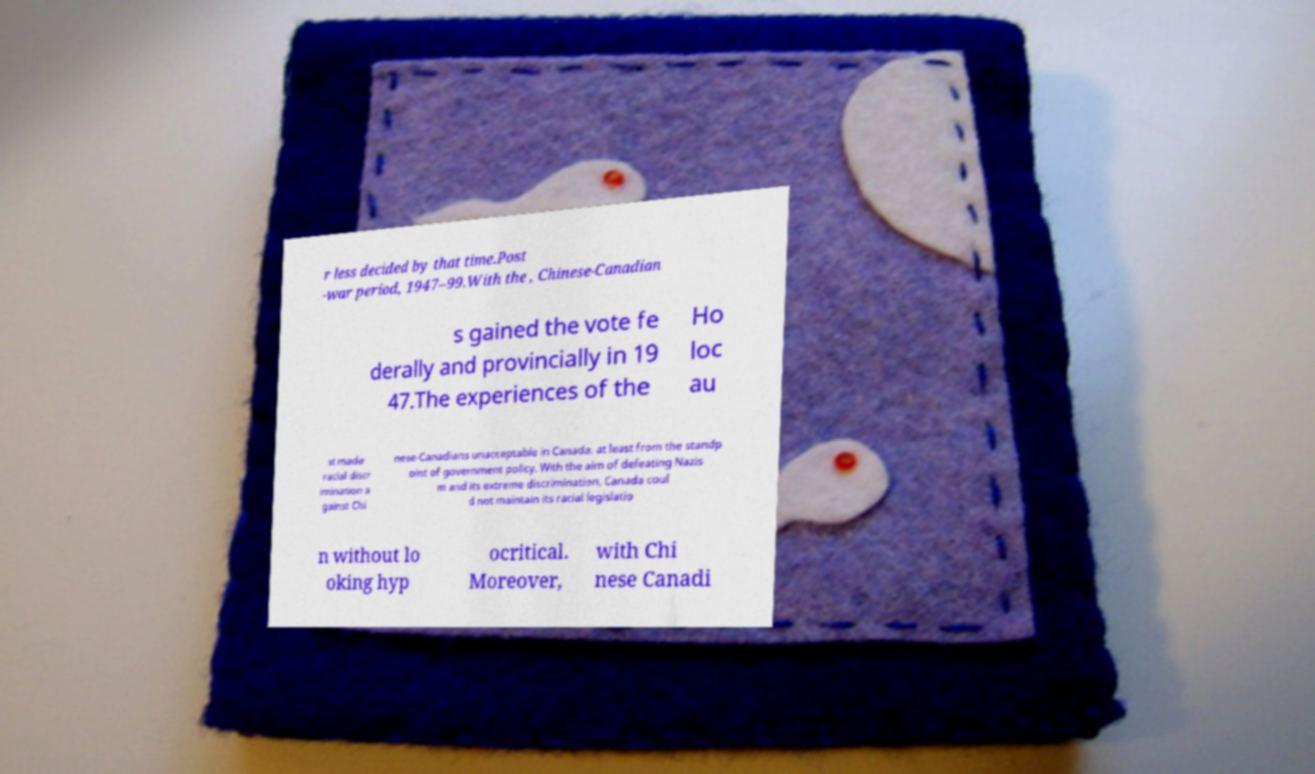There's text embedded in this image that I need extracted. Can you transcribe it verbatim? r less decided by that time.Post -war period, 1947–99.With the , Chinese-Canadian s gained the vote fe derally and provincially in 19 47.The experiences of the Ho loc au st made racial discr imination a gainst Chi nese-Canadians unacceptable in Canada, at least from the standp oint of government policy. With the aim of defeating Nazis m and its extreme discrimination, Canada coul d not maintain its racial legislatio n without lo oking hyp ocritical. Moreover, with Chi nese Canadi 